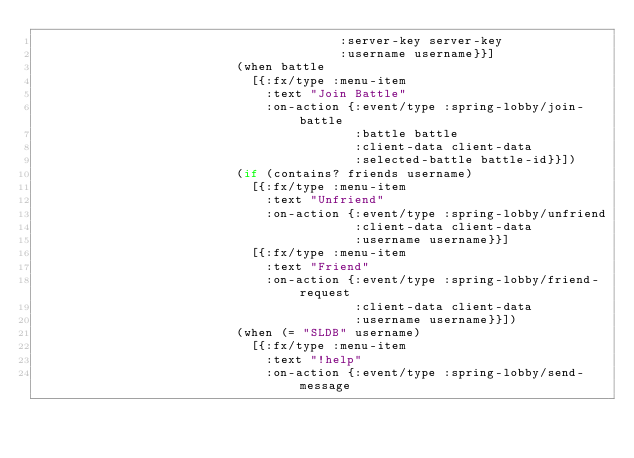Convert code to text. <code><loc_0><loc_0><loc_500><loc_500><_Clojure_>                                         :server-key server-key
                                         :username username}}]
                           (when battle
                             [{:fx/type :menu-item
                               :text "Join Battle"
                               :on-action {:event/type :spring-lobby/join-battle
                                           :battle battle
                                           :client-data client-data
                                           :selected-battle battle-id}}])
                           (if (contains? friends username)
                             [{:fx/type :menu-item
                               :text "Unfriend"
                               :on-action {:event/type :spring-lobby/unfriend
                                           :client-data client-data
                                           :username username}}]
                             [{:fx/type :menu-item
                               :text "Friend"
                               :on-action {:event/type :spring-lobby/friend-request
                                           :client-data client-data
                                           :username username}}])
                           (when (= "SLDB" username)
                             [{:fx/type :menu-item
                               :text "!help"
                               :on-action {:event/type :spring-lobby/send-message</code> 